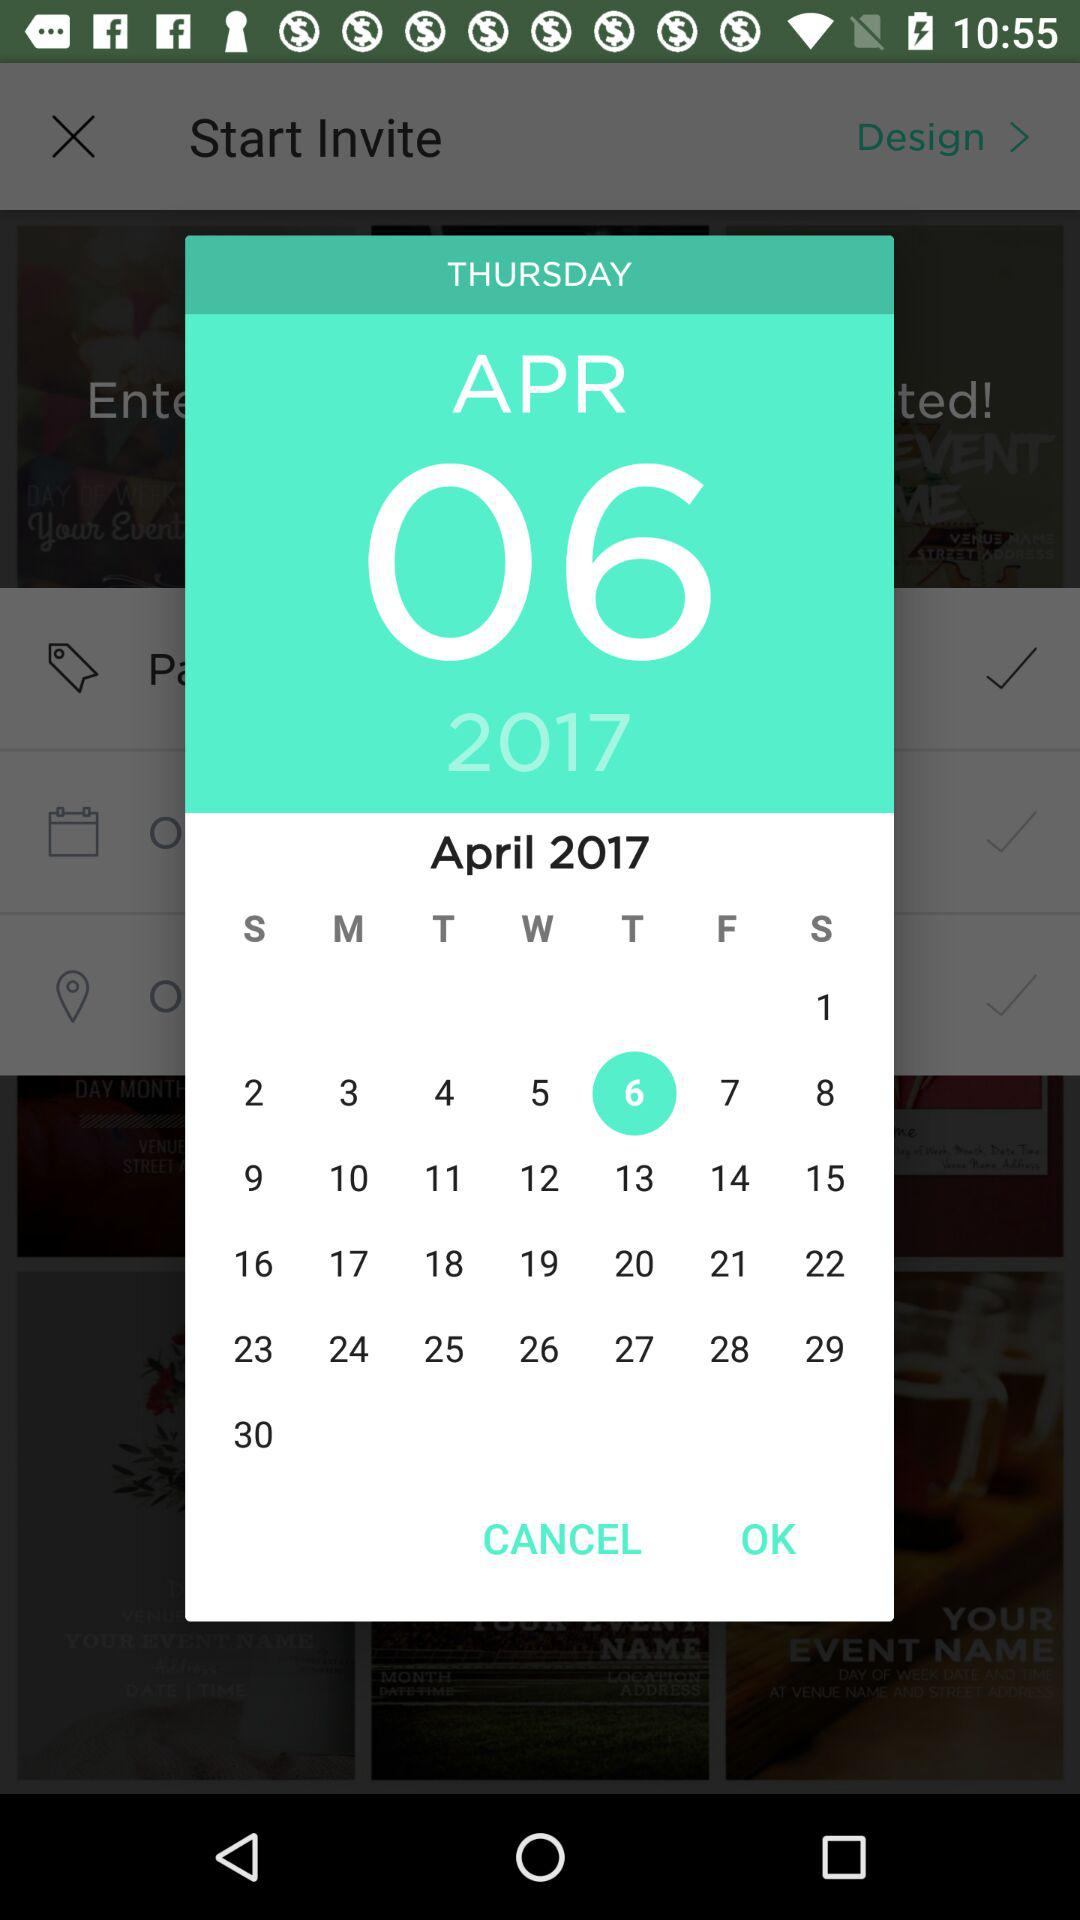Which day falls on April 6th? The day is Thursday. 